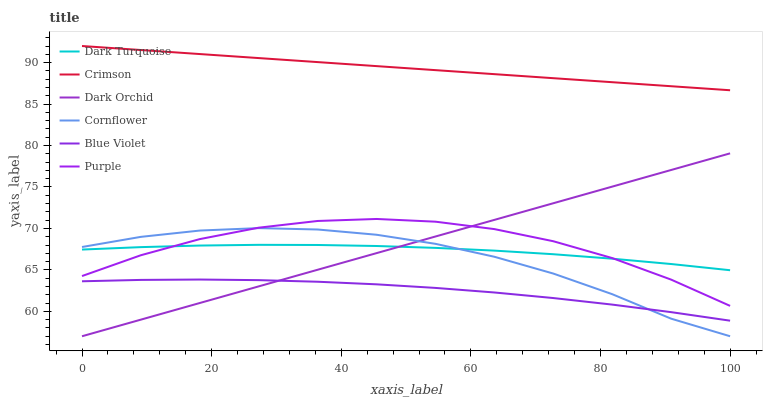Does Blue Violet have the minimum area under the curve?
Answer yes or no. Yes. Does Crimson have the maximum area under the curve?
Answer yes or no. Yes. Does Purple have the minimum area under the curve?
Answer yes or no. No. Does Purple have the maximum area under the curve?
Answer yes or no. No. Is Crimson the smoothest?
Answer yes or no. Yes. Is Purple the roughest?
Answer yes or no. Yes. Is Dark Turquoise the smoothest?
Answer yes or no. No. Is Dark Turquoise the roughest?
Answer yes or no. No. Does Cornflower have the lowest value?
Answer yes or no. Yes. Does Purple have the lowest value?
Answer yes or no. No. Does Crimson have the highest value?
Answer yes or no. Yes. Does Purple have the highest value?
Answer yes or no. No. Is Blue Violet less than Crimson?
Answer yes or no. Yes. Is Crimson greater than Blue Violet?
Answer yes or no. Yes. Does Cornflower intersect Dark Orchid?
Answer yes or no. Yes. Is Cornflower less than Dark Orchid?
Answer yes or no. No. Is Cornflower greater than Dark Orchid?
Answer yes or no. No. Does Blue Violet intersect Crimson?
Answer yes or no. No. 